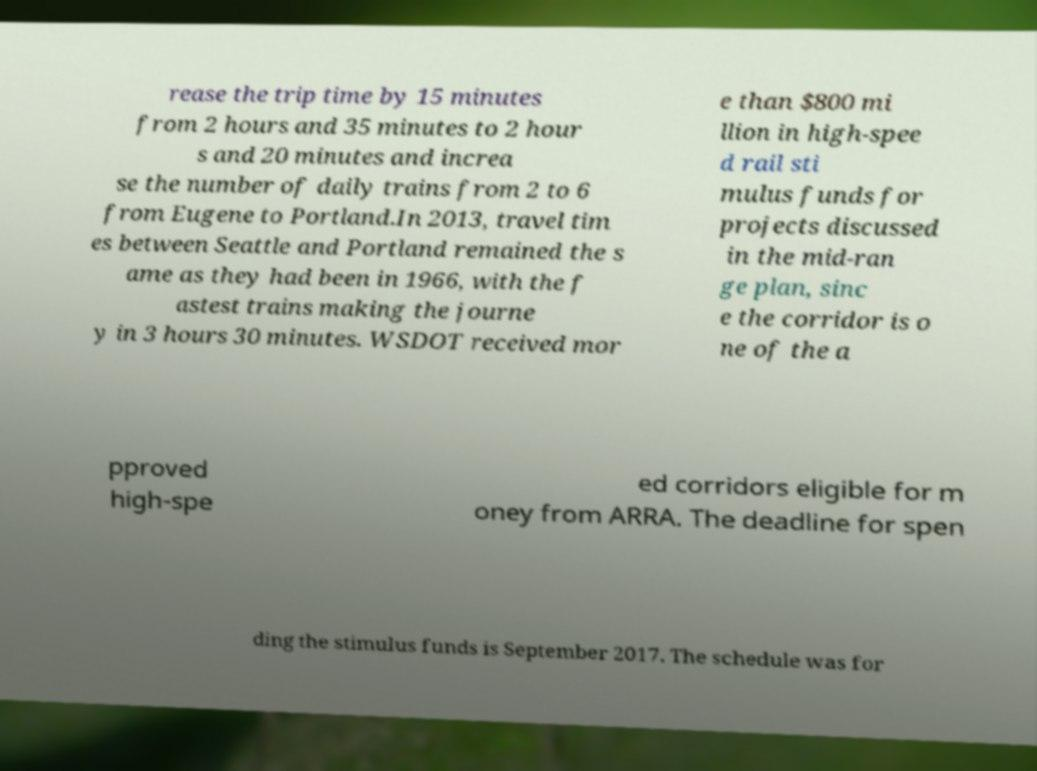Can you accurately transcribe the text from the provided image for me? rease the trip time by 15 minutes from 2 hours and 35 minutes to 2 hour s and 20 minutes and increa se the number of daily trains from 2 to 6 from Eugene to Portland.In 2013, travel tim es between Seattle and Portland remained the s ame as they had been in 1966, with the f astest trains making the journe y in 3 hours 30 minutes. WSDOT received mor e than $800 mi llion in high-spee d rail sti mulus funds for projects discussed in the mid-ran ge plan, sinc e the corridor is o ne of the a pproved high-spe ed corridors eligible for m oney from ARRA. The deadline for spen ding the stimulus funds is September 2017. The schedule was for 